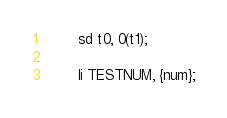<code> <loc_0><loc_0><loc_500><loc_500><_YAML_>        sd t0, 0(t1);

        li TESTNUM, {num};</code> 